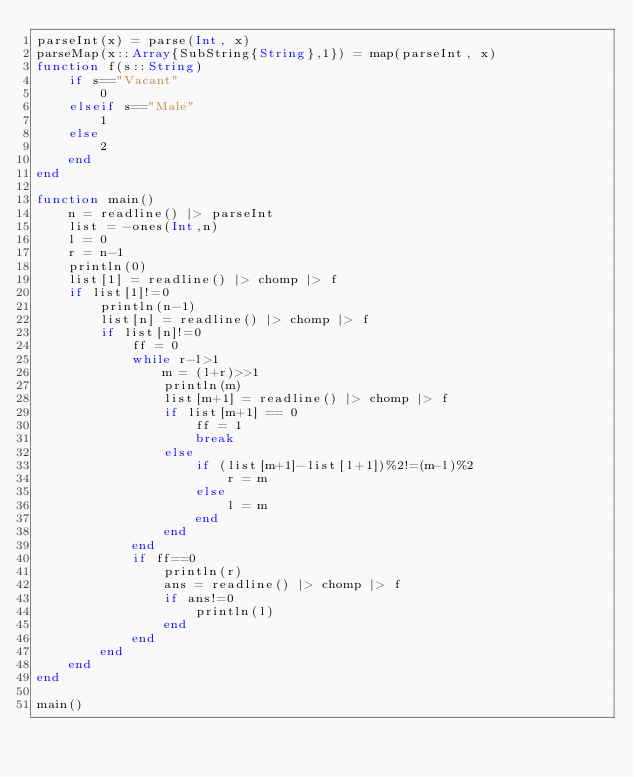<code> <loc_0><loc_0><loc_500><loc_500><_Julia_>parseInt(x) = parse(Int, x)
parseMap(x::Array{SubString{String},1}) = map(parseInt, x)
function f(s::String)
	if s=="Vacant"
		0
	elseif s=="Male"
		1
	else
		2
	end
end

function main()
	n = readline() |> parseInt
	list = -ones(Int,n)
	l = 0
	r = n-1
	println(0)
	list[1] = readline() |> chomp |> f
	if list[1]!=0
		println(n-1)
		list[n] = readline() |> chomp |> f
		if list[n]!=0
			ff = 0
			while r-l>1
				m = (l+r)>>1
				println(m)
				list[m+1] = readline() |> chomp |> f
				if list[m+1] == 0
					ff = 1
					break
				else
					if (list[m+1]-list[l+1])%2!=(m-l)%2
						r = m
					else
						l = m
					end
				end
			end
			if ff==0
				println(r)
				ans = readline() |> chomp |> f
				if ans!=0
					println(l)
				end
			end
		end
	end	
end

main()</code> 